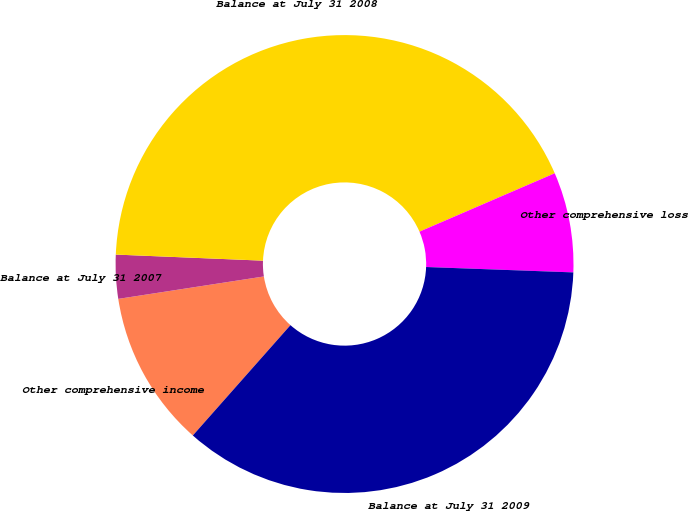<chart> <loc_0><loc_0><loc_500><loc_500><pie_chart><fcel>Other comprehensive income<fcel>Balance at July 31 2007<fcel>Balance at July 31 2008<fcel>Other comprehensive loss<fcel>Balance at July 31 2009<nl><fcel>11.04%<fcel>3.09%<fcel>42.86%<fcel>7.07%<fcel>35.95%<nl></chart> 